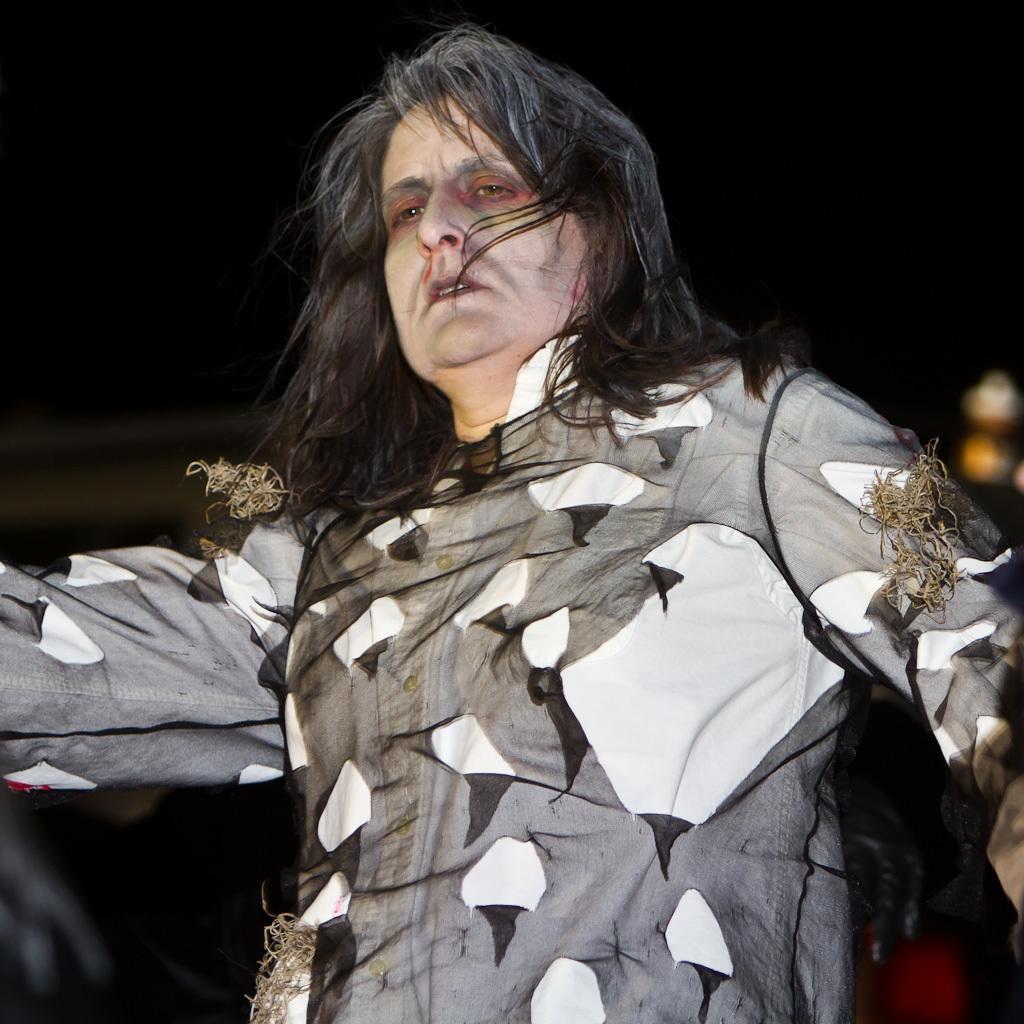Describe this image in one or two sentences. A person is standing wearing clothes. 